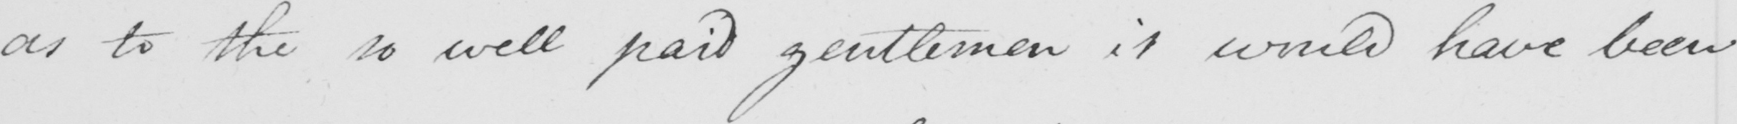Can you read and transcribe this handwriting? as to the so well paid gentlemen it would have been 